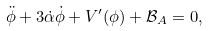<formula> <loc_0><loc_0><loc_500><loc_500>\ddot { \phi } + 3 \dot { \alpha } \dot { \phi } + V ^ { \prime } ( \phi ) + \mathcal { B } _ { A } = 0 ,</formula> 